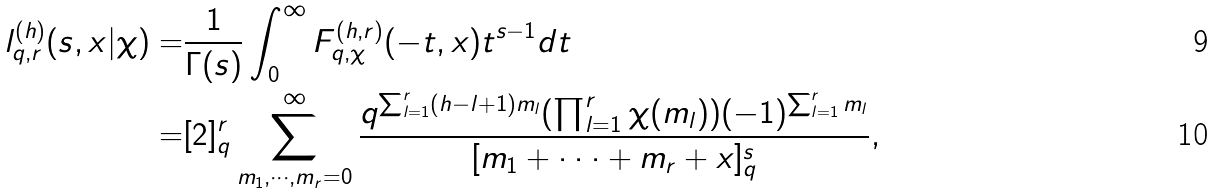<formula> <loc_0><loc_0><loc_500><loc_500>\ l _ { q , r } ^ { ( h ) } ( s , x | \chi ) = & \frac { 1 } { \Gamma ( s ) } \int _ { 0 } ^ { \infty } F _ { q , { \chi } } ^ { ( h , r ) } ( - t , x ) t ^ { s - 1 } d t \\ = & [ 2 ] _ { q } ^ { r } \sum _ { m _ { 1 } , \cdot \cdot \cdot , m _ { r } = 0 } ^ { \infty } \frac { q ^ { \sum _ { l = 1 } ^ { r } ( h - l + 1 ) m _ { l } } ( \prod _ { l = 1 } ^ { r } \chi ( m _ { l } ) ) ( - 1 ) ^ { \sum _ { l = 1 } ^ { r } m _ { l } } } { [ m _ { 1 } + \cdot \cdot \cdot + m _ { r } + x ] _ { q } ^ { s } } ,</formula> 